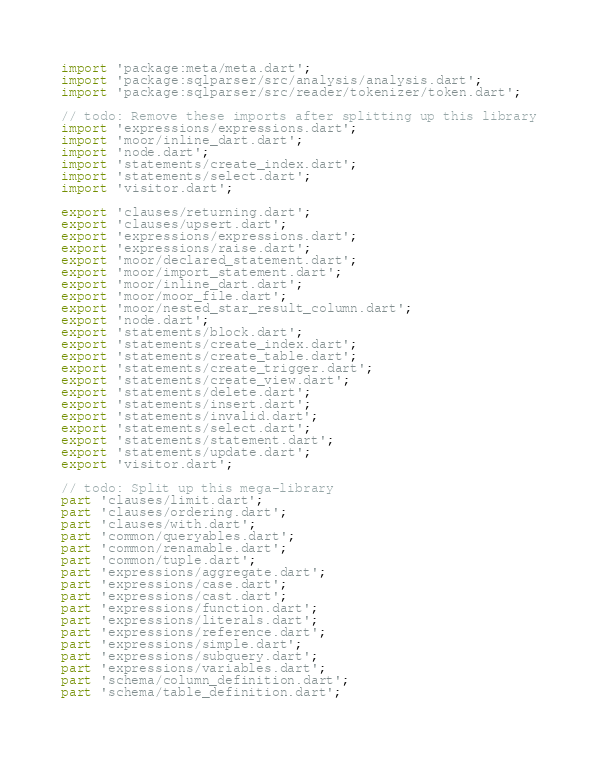<code> <loc_0><loc_0><loc_500><loc_500><_Dart_>import 'package:meta/meta.dart';
import 'package:sqlparser/src/analysis/analysis.dart';
import 'package:sqlparser/src/reader/tokenizer/token.dart';

// todo: Remove these imports after splitting up this library
import 'expressions/expressions.dart';
import 'moor/inline_dart.dart';
import 'node.dart';
import 'statements/create_index.dart';
import 'statements/select.dart';
import 'visitor.dart';

export 'clauses/returning.dart';
export 'clauses/upsert.dart';
export 'expressions/expressions.dart';
export 'expressions/raise.dart';
export 'moor/declared_statement.dart';
export 'moor/import_statement.dart';
export 'moor/inline_dart.dart';
export 'moor/moor_file.dart';
export 'moor/nested_star_result_column.dart';
export 'node.dart';
export 'statements/block.dart';
export 'statements/create_index.dart';
export 'statements/create_table.dart';
export 'statements/create_trigger.dart';
export 'statements/create_view.dart';
export 'statements/delete.dart';
export 'statements/insert.dart';
export 'statements/invalid.dart';
export 'statements/select.dart';
export 'statements/statement.dart';
export 'statements/update.dart';
export 'visitor.dart';

// todo: Split up this mega-library
part 'clauses/limit.dart';
part 'clauses/ordering.dart';
part 'clauses/with.dart';
part 'common/queryables.dart';
part 'common/renamable.dart';
part 'common/tuple.dart';
part 'expressions/aggregate.dart';
part 'expressions/case.dart';
part 'expressions/cast.dart';
part 'expressions/function.dart';
part 'expressions/literals.dart';
part 'expressions/reference.dart';
part 'expressions/simple.dart';
part 'expressions/subquery.dart';
part 'expressions/variables.dart';
part 'schema/column_definition.dart';
part 'schema/table_definition.dart';
</code> 